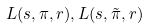<formula> <loc_0><loc_0><loc_500><loc_500>L ( s , \pi , r ) , L ( s , \tilde { \pi } , r )</formula> 